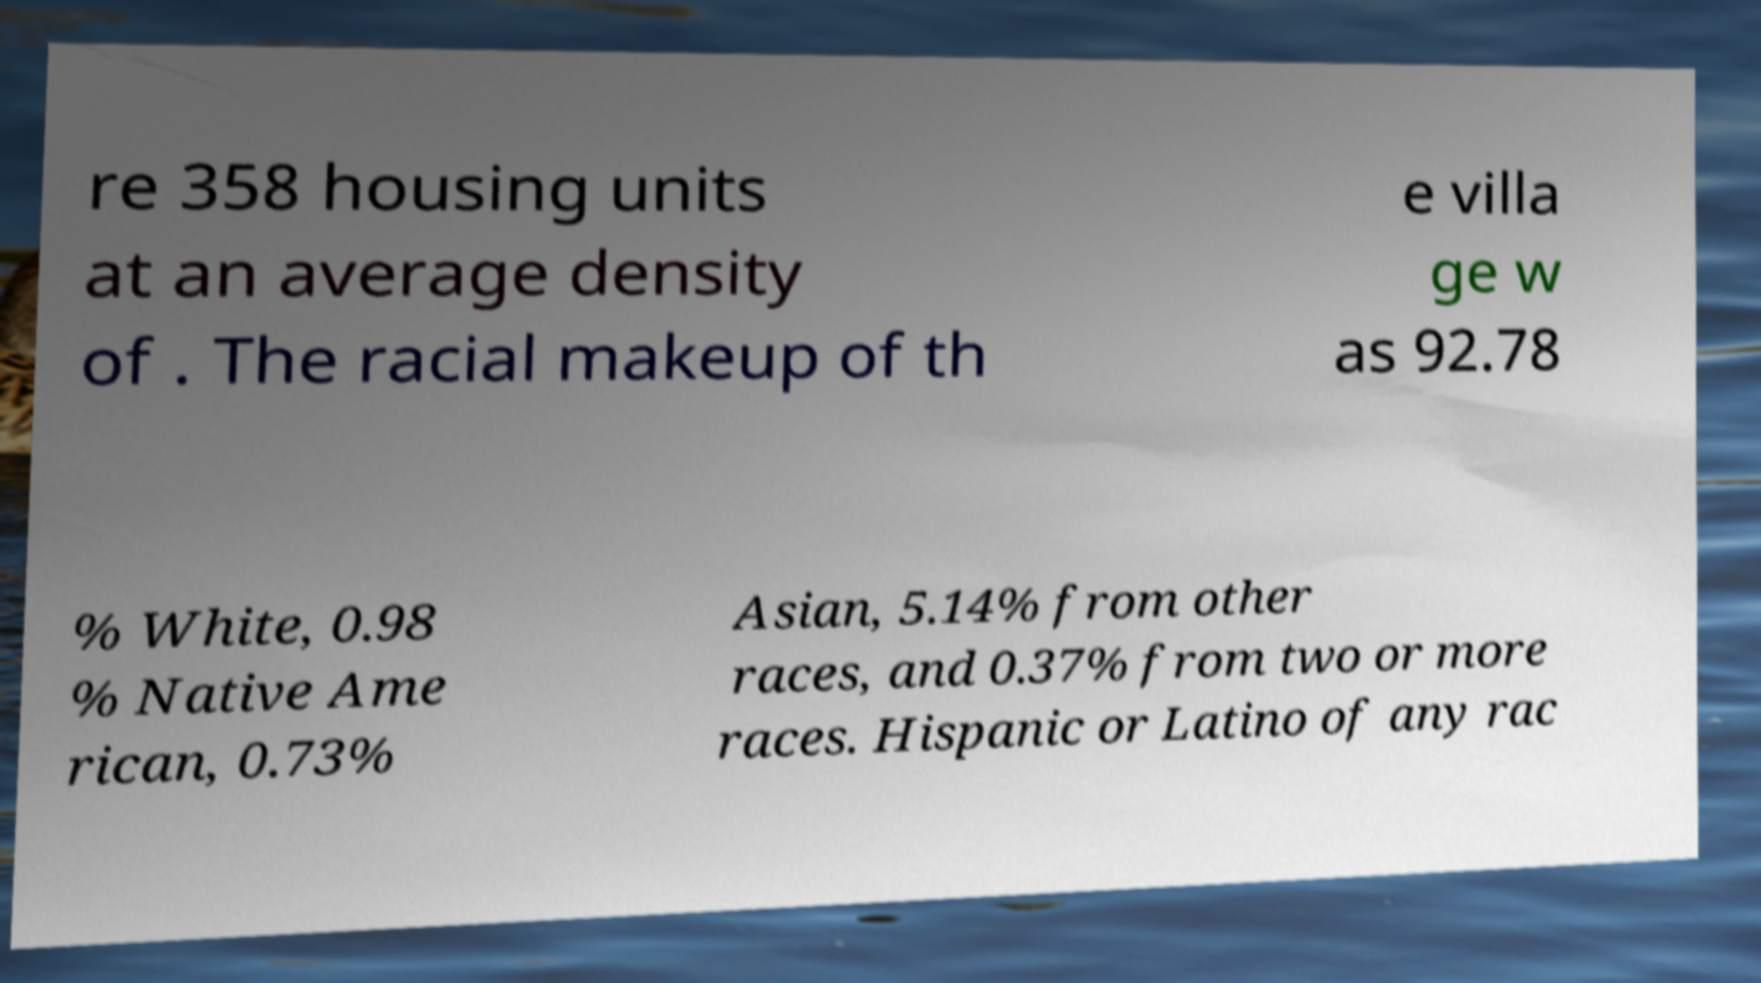Can you accurately transcribe the text from the provided image for me? re 358 housing units at an average density of . The racial makeup of th e villa ge w as 92.78 % White, 0.98 % Native Ame rican, 0.73% Asian, 5.14% from other races, and 0.37% from two or more races. Hispanic or Latino of any rac 